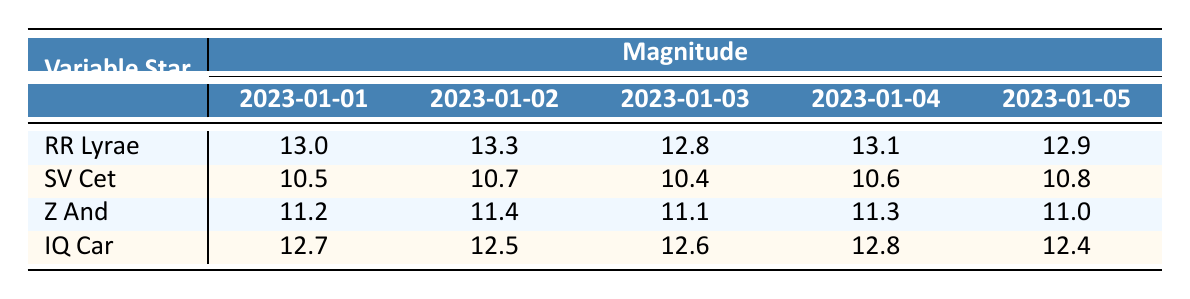What was the magnitude of RR Lyrae on January 3, 2023? From the table, under the row for RR Lyrae, the column for January 3, 2023 shows a magnitude of 12.8.
Answer: 12.8 What is the highest magnitude observed for SV Cet during the given dates? Looking at the row for SV Cet, the magnitudes are 10.5, 10.7, 10.4, 10.6, and 10.8. The highest value among these is 10.8.
Answer: 10.8 Was there a decrease in magnitude for Z And from January 2 to January 3, 2023? For Z And, the magnitude on January 2 is 11.4, and on January 3, it is 11.1. Since 11.1 is less than 11.4, this indicates a decrease.
Answer: Yes Calculate the average magnitude of IQ Car over the specified dates. The magnitudes for IQ Car are 12.7, 12.5, 12.6, 12.8, and 12.4. Adding these gives 12.7 + 12.5 + 12.6 + 12.8 + 12.4 = 63.0. There are 5 data points, so the average is 63.0 / 5 = 12.6.
Answer: 12.6 For which variable star was the magnitude closest to 13.0 on January 4, 2023? The table shows that RR Lyrae had a magnitude of 13.1 and SV Cet had a magnitude of 10.6. Z And had a magnitude of 11.3, and IQ Car had a magnitude of 12.8. The closest value to 13.0 is 13.1 for RR Lyrae.
Answer: RR Lyrae 